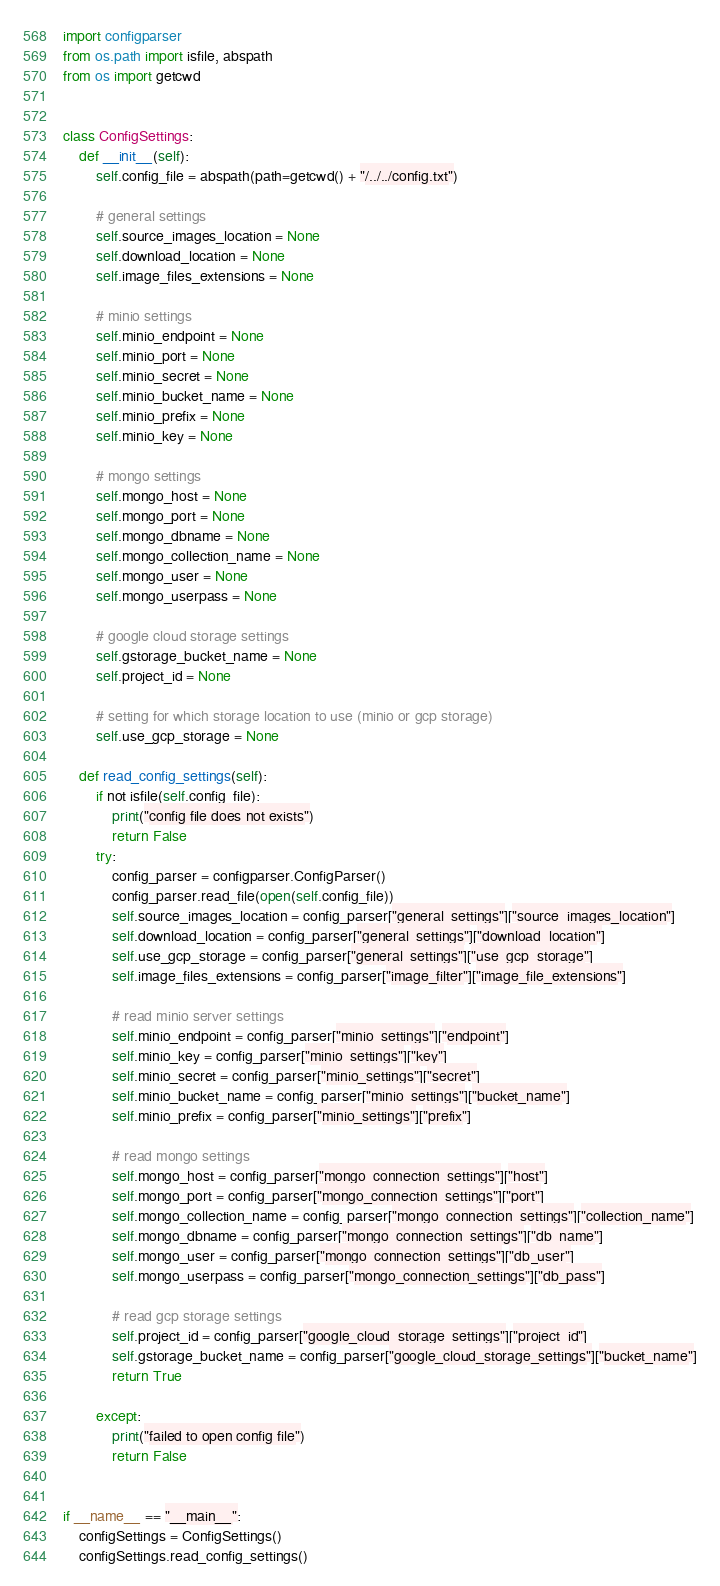Convert code to text. <code><loc_0><loc_0><loc_500><loc_500><_Python_>import configparser
from os.path import isfile, abspath
from os import getcwd


class ConfigSettings:
    def __init__(self):
        self.config_file = abspath(path=getcwd() + "/../../config.txt")

        # general settings
        self.source_images_location = None
        self.download_location = None
        self.image_files_extensions = None

        # minio settings
        self.minio_endpoint = None
        self.minio_port = None
        self.minio_secret = None
        self.minio_bucket_name = None
        self.minio_prefix = None
        self.minio_key = None

        # mongo settings
        self.mongo_host = None
        self.mongo_port = None
        self.mongo_dbname = None
        self.mongo_collection_name = None
        self.mongo_user = None
        self.mongo_userpass = None

        # google cloud storage settings
        self.gstorage_bucket_name = None
        self.project_id = None

        # setting for which storage location to use (minio or gcp storage)
        self.use_gcp_storage = None

    def read_config_settings(self):
        if not isfile(self.config_file):
            print("config file does not exists")
            return False
        try:
            config_parser = configparser.ConfigParser()
            config_parser.read_file(open(self.config_file))
            self.source_images_location = config_parser["general_settings"]["source_images_location"]
            self.download_location = config_parser["general_settings"]["download_location"]
            self.use_gcp_storage = config_parser["general_settings"]["use_gcp_storage"]
            self.image_files_extensions = config_parser["image_filter"]["image_file_extensions"]

            # read minio server settings
            self.minio_endpoint = config_parser["minio_settings"]["endpoint"]
            self.minio_key = config_parser["minio_settings"]["key"]
            self.minio_secret = config_parser["minio_settings"]["secret"]
            self.minio_bucket_name = config_parser["minio_settings"]["bucket_name"]
            self.minio_prefix = config_parser["minio_settings"]["prefix"]

            # read mongo settings
            self.mongo_host = config_parser["mongo_connection_settings"]["host"]
            self.mongo_port = config_parser["mongo_connection_settings"]["port"]
            self.mongo_collection_name = config_parser["mongo_connection_settings"]["collection_name"]
            self.mongo_dbname = config_parser["mongo_connection_settings"]["db_name"]
            self.mongo_user = config_parser["mongo_connection_settings"]["db_user"]
            self.mongo_userpass = config_parser["mongo_connection_settings"]["db_pass"]

            # read gcp storage settings
            self.project_id = config_parser["google_cloud_storage_settings"]["project_id"]
            self.gstorage_bucket_name = config_parser["google_cloud_storage_settings"]["bucket_name"]
            return True

        except:
            print("failed to open config file")
            return False


if __name__ == "__main__":
    configSettings = ConfigSettings()
    configSettings.read_config_settings()
</code> 